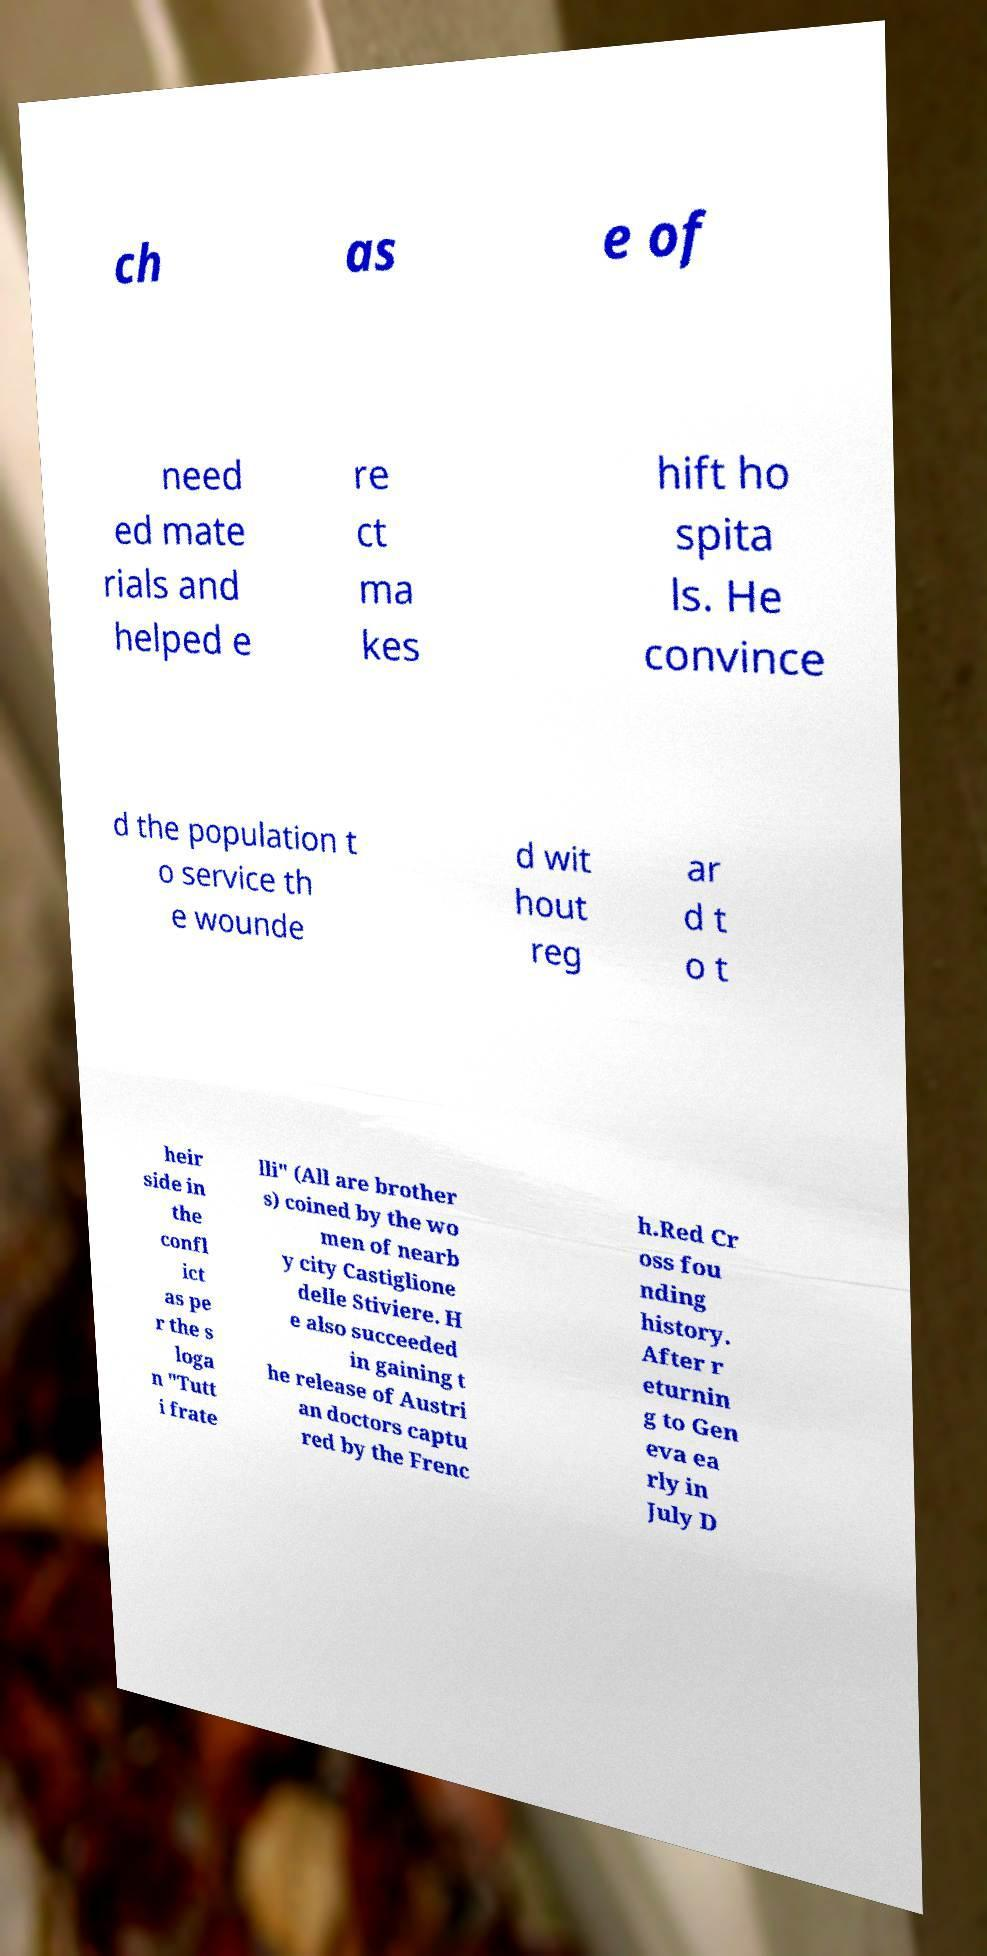Could you assist in decoding the text presented in this image and type it out clearly? ch as e of need ed mate rials and helped e re ct ma kes hift ho spita ls. He convince d the population t o service th e wounde d wit hout reg ar d t o t heir side in the confl ict as pe r the s loga n "Tutt i frate lli" (All are brother s) coined by the wo men of nearb y city Castiglione delle Stiviere. H e also succeeded in gaining t he release of Austri an doctors captu red by the Frenc h.Red Cr oss fou nding history. After r eturnin g to Gen eva ea rly in July D 